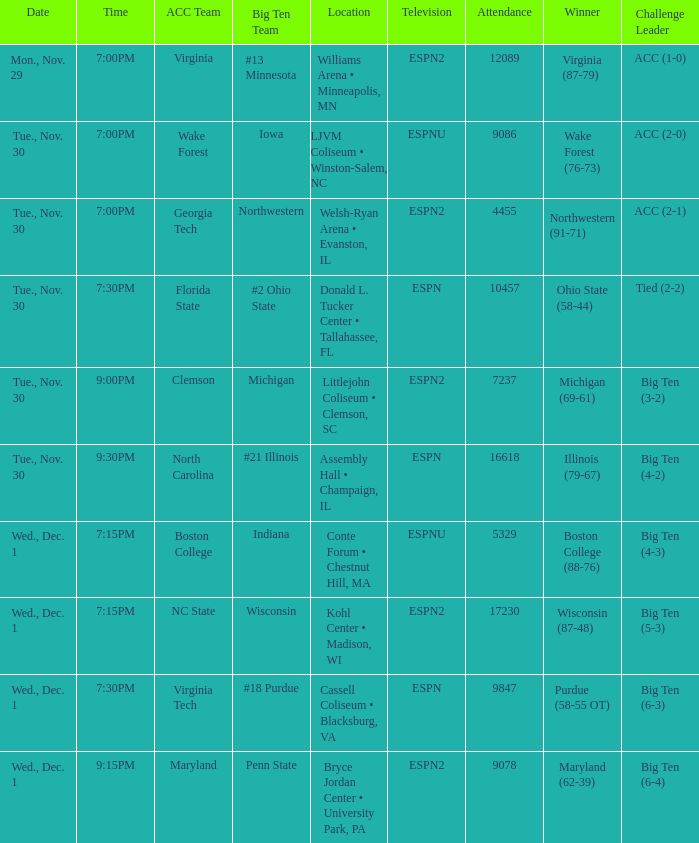How many challenge leaders were there of the games won by virginia (87-79)? 1.0. 